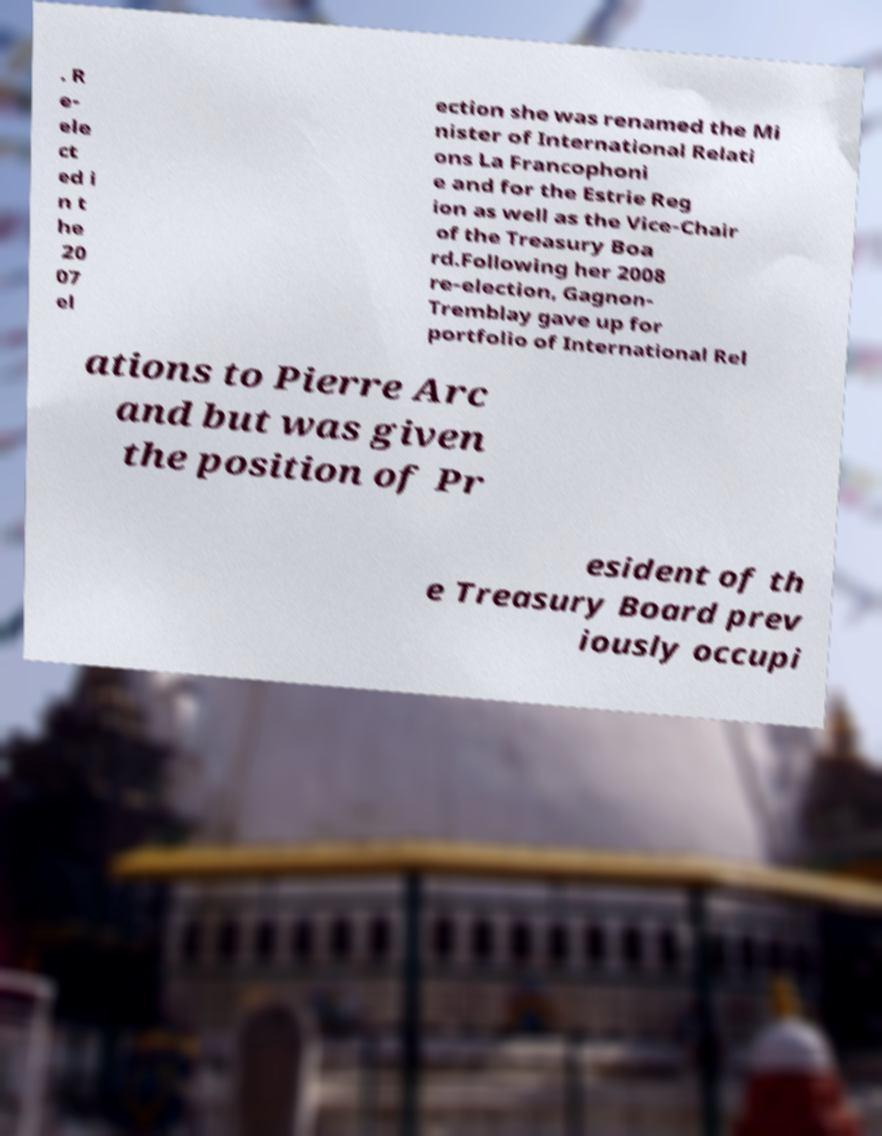There's text embedded in this image that I need extracted. Can you transcribe it verbatim? . R e- ele ct ed i n t he 20 07 el ection she was renamed the Mi nister of International Relati ons La Francophoni e and for the Estrie Reg ion as well as the Vice-Chair of the Treasury Boa rd.Following her 2008 re-election, Gagnon- Tremblay gave up for portfolio of International Rel ations to Pierre Arc and but was given the position of Pr esident of th e Treasury Board prev iously occupi 